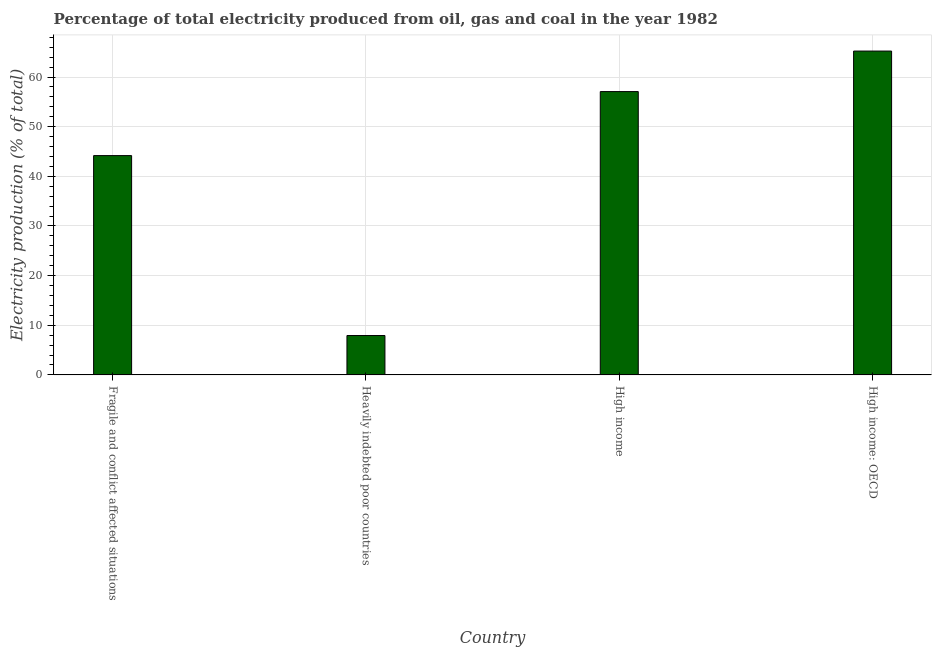What is the title of the graph?
Your answer should be compact. Percentage of total electricity produced from oil, gas and coal in the year 1982. What is the label or title of the X-axis?
Keep it short and to the point. Country. What is the label or title of the Y-axis?
Your answer should be compact. Electricity production (% of total). What is the electricity production in Fragile and conflict affected situations?
Provide a short and direct response. 44.18. Across all countries, what is the maximum electricity production?
Offer a very short reply. 65.23. Across all countries, what is the minimum electricity production?
Make the answer very short. 7.93. In which country was the electricity production maximum?
Offer a very short reply. High income: OECD. In which country was the electricity production minimum?
Provide a short and direct response. Heavily indebted poor countries. What is the sum of the electricity production?
Offer a terse response. 174.41. What is the difference between the electricity production in High income and High income: OECD?
Offer a terse response. -8.16. What is the average electricity production per country?
Your answer should be compact. 43.6. What is the median electricity production?
Give a very brief answer. 50.62. What is the ratio of the electricity production in Fragile and conflict affected situations to that in High income: OECD?
Keep it short and to the point. 0.68. Is the electricity production in Fragile and conflict affected situations less than that in High income: OECD?
Ensure brevity in your answer.  Yes. Is the difference between the electricity production in Fragile and conflict affected situations and High income: OECD greater than the difference between any two countries?
Offer a very short reply. No. What is the difference between the highest and the second highest electricity production?
Provide a short and direct response. 8.16. Is the sum of the electricity production in Fragile and conflict affected situations and Heavily indebted poor countries greater than the maximum electricity production across all countries?
Ensure brevity in your answer.  No. What is the difference between the highest and the lowest electricity production?
Provide a short and direct response. 57.3. Are all the bars in the graph horizontal?
Ensure brevity in your answer.  No. Are the values on the major ticks of Y-axis written in scientific E-notation?
Give a very brief answer. No. What is the Electricity production (% of total) of Fragile and conflict affected situations?
Give a very brief answer. 44.18. What is the Electricity production (% of total) of Heavily indebted poor countries?
Offer a terse response. 7.93. What is the Electricity production (% of total) of High income?
Give a very brief answer. 57.07. What is the Electricity production (% of total) in High income: OECD?
Offer a very short reply. 65.23. What is the difference between the Electricity production (% of total) in Fragile and conflict affected situations and Heavily indebted poor countries?
Keep it short and to the point. 36.24. What is the difference between the Electricity production (% of total) in Fragile and conflict affected situations and High income?
Offer a very short reply. -12.89. What is the difference between the Electricity production (% of total) in Fragile and conflict affected situations and High income: OECD?
Your answer should be compact. -21.05. What is the difference between the Electricity production (% of total) in Heavily indebted poor countries and High income?
Keep it short and to the point. -49.14. What is the difference between the Electricity production (% of total) in Heavily indebted poor countries and High income: OECD?
Your response must be concise. -57.3. What is the difference between the Electricity production (% of total) in High income and High income: OECD?
Your response must be concise. -8.16. What is the ratio of the Electricity production (% of total) in Fragile and conflict affected situations to that in Heavily indebted poor countries?
Provide a succinct answer. 5.57. What is the ratio of the Electricity production (% of total) in Fragile and conflict affected situations to that in High income?
Your response must be concise. 0.77. What is the ratio of the Electricity production (% of total) in Fragile and conflict affected situations to that in High income: OECD?
Give a very brief answer. 0.68. What is the ratio of the Electricity production (% of total) in Heavily indebted poor countries to that in High income?
Offer a terse response. 0.14. What is the ratio of the Electricity production (% of total) in Heavily indebted poor countries to that in High income: OECD?
Your answer should be compact. 0.12. What is the ratio of the Electricity production (% of total) in High income to that in High income: OECD?
Provide a short and direct response. 0.88. 